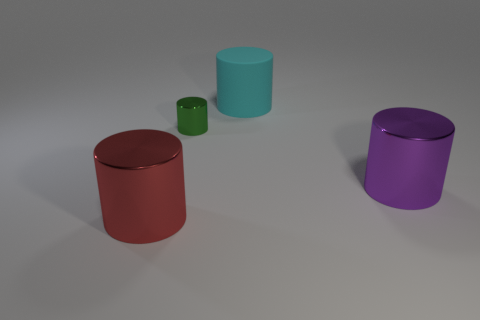Subtract all red cylinders. How many cylinders are left? 3 Add 3 metallic cylinders. How many objects exist? 7 Subtract all purple cylinders. How many cylinders are left? 3 Subtract 2 cylinders. How many cylinders are left? 2 Subtract all large purple cylinders. Subtract all brown rubber things. How many objects are left? 3 Add 2 big cylinders. How many big cylinders are left? 5 Add 4 small metal cylinders. How many small metal cylinders exist? 5 Subtract 0 yellow cylinders. How many objects are left? 4 Subtract all purple cylinders. Subtract all red cubes. How many cylinders are left? 3 Subtract all yellow balls. How many red cylinders are left? 1 